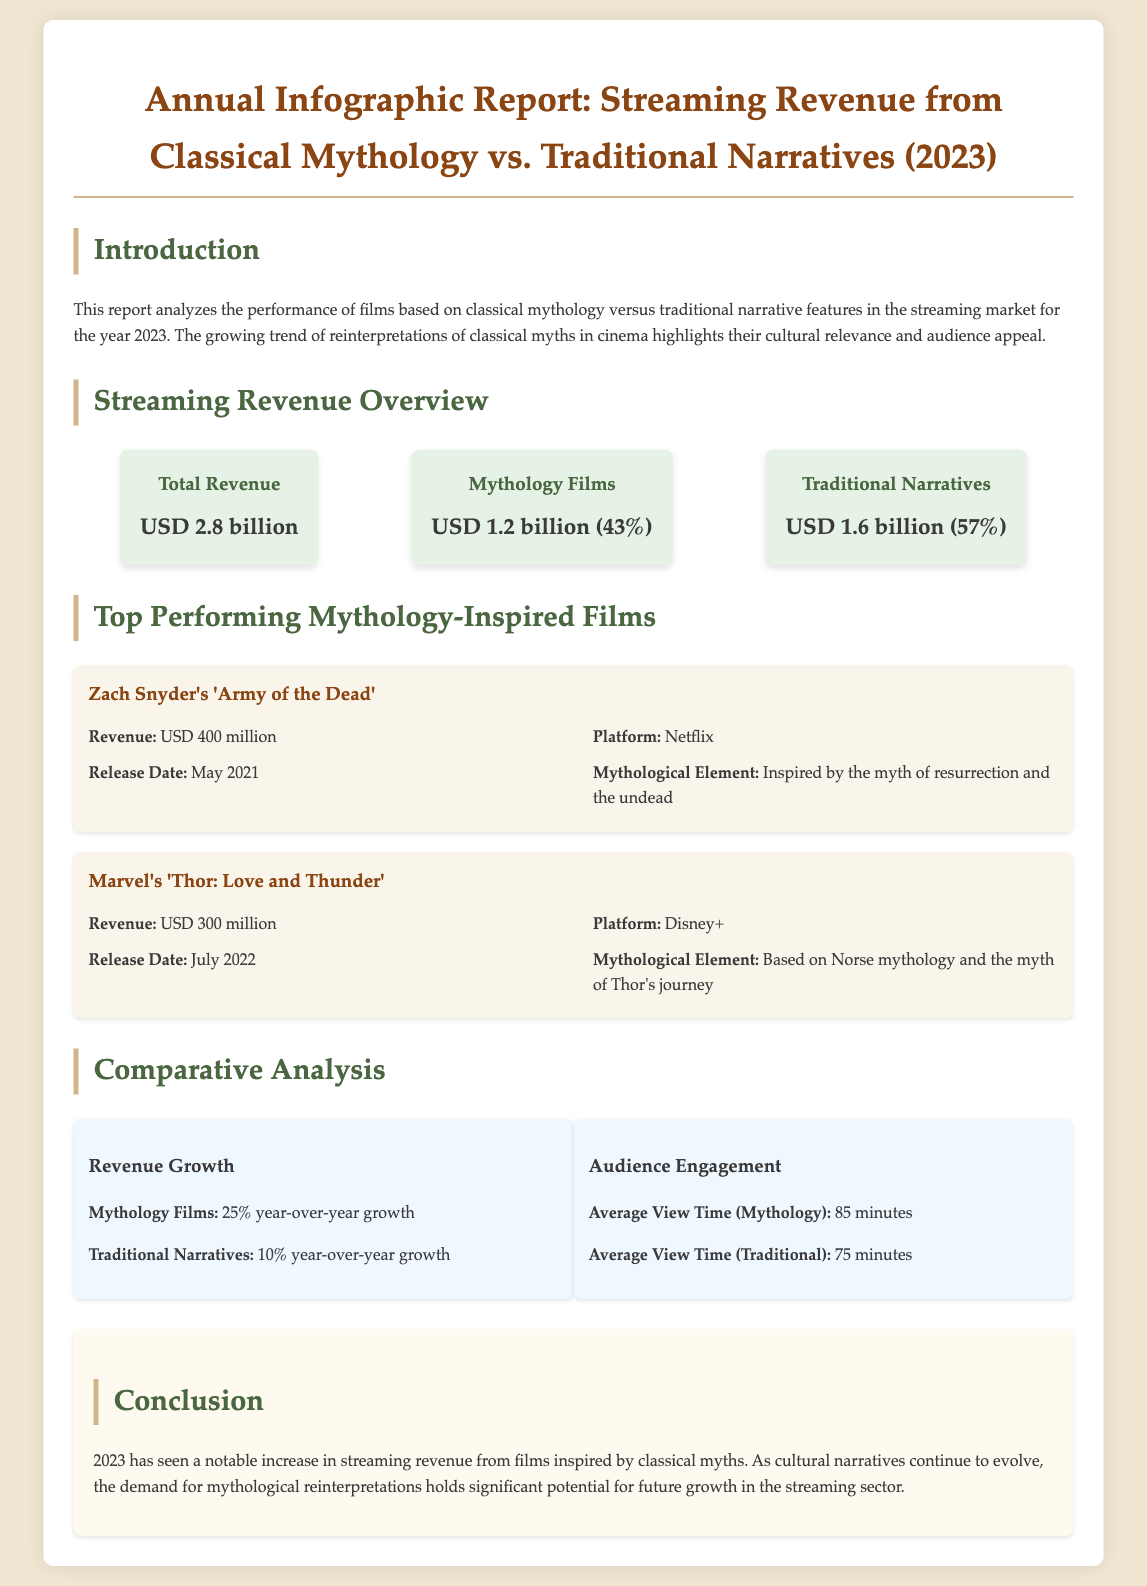what is the total revenue? The document states that the total revenue generated from films in 2023 is USD 2.8 billion.
Answer: USD 2.8 billion how much revenue was generated from mythology films? The document specifies that the revenue from mythology films in 2023 is USD 1.2 billion, which accounts for 43% of total revenue.
Answer: USD 1.2 billion which film generated the highest revenue among mythology films? According to the document, 'Army of the Dead' generated the highest revenue among mythology films with USD 400 million.
Answer: 'Army of the Dead' what is the average view time for traditional narrative films? The document mentions that the average view time for traditional narrative films is 75 minutes.
Answer: 75 minutes what percentage of the total revenue comes from traditional narratives? The document states that traditional narratives account for 57% of total revenue.
Answer: 57% what is the year-over-year growth of revenue for mythology films? The report indicates that mythology films experienced a 25% year-over-year growth.
Answer: 25% how many mythology-inspired films are listed in the document? The document lists two mythology-inspired films under the top performing category.
Answer: 2 what platform aired 'Thor: Love and Thunder'? The document identifies that 'Thor: Love and Thunder' was released on Disney+.
Answer: Disney+ what is the conclusion regarding mythology films in 2023? The conclusion states that there has been a notable increase in streaming revenue from mythology films, highlighting their cultural relevance.
Answer: Notable increase in revenue 